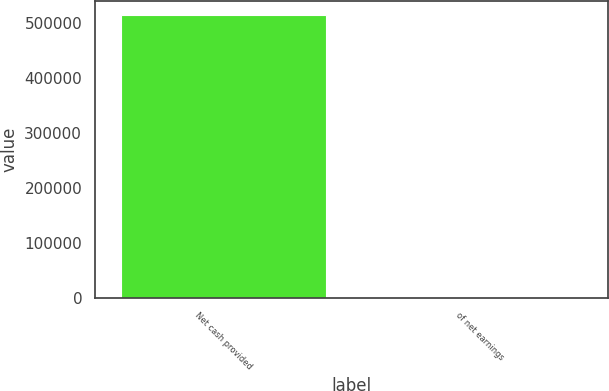<chart> <loc_0><loc_0><loc_500><loc_500><bar_chart><fcel>Net cash provided<fcel>of net earnings<nl><fcel>513999<fcel>102.9<nl></chart> 